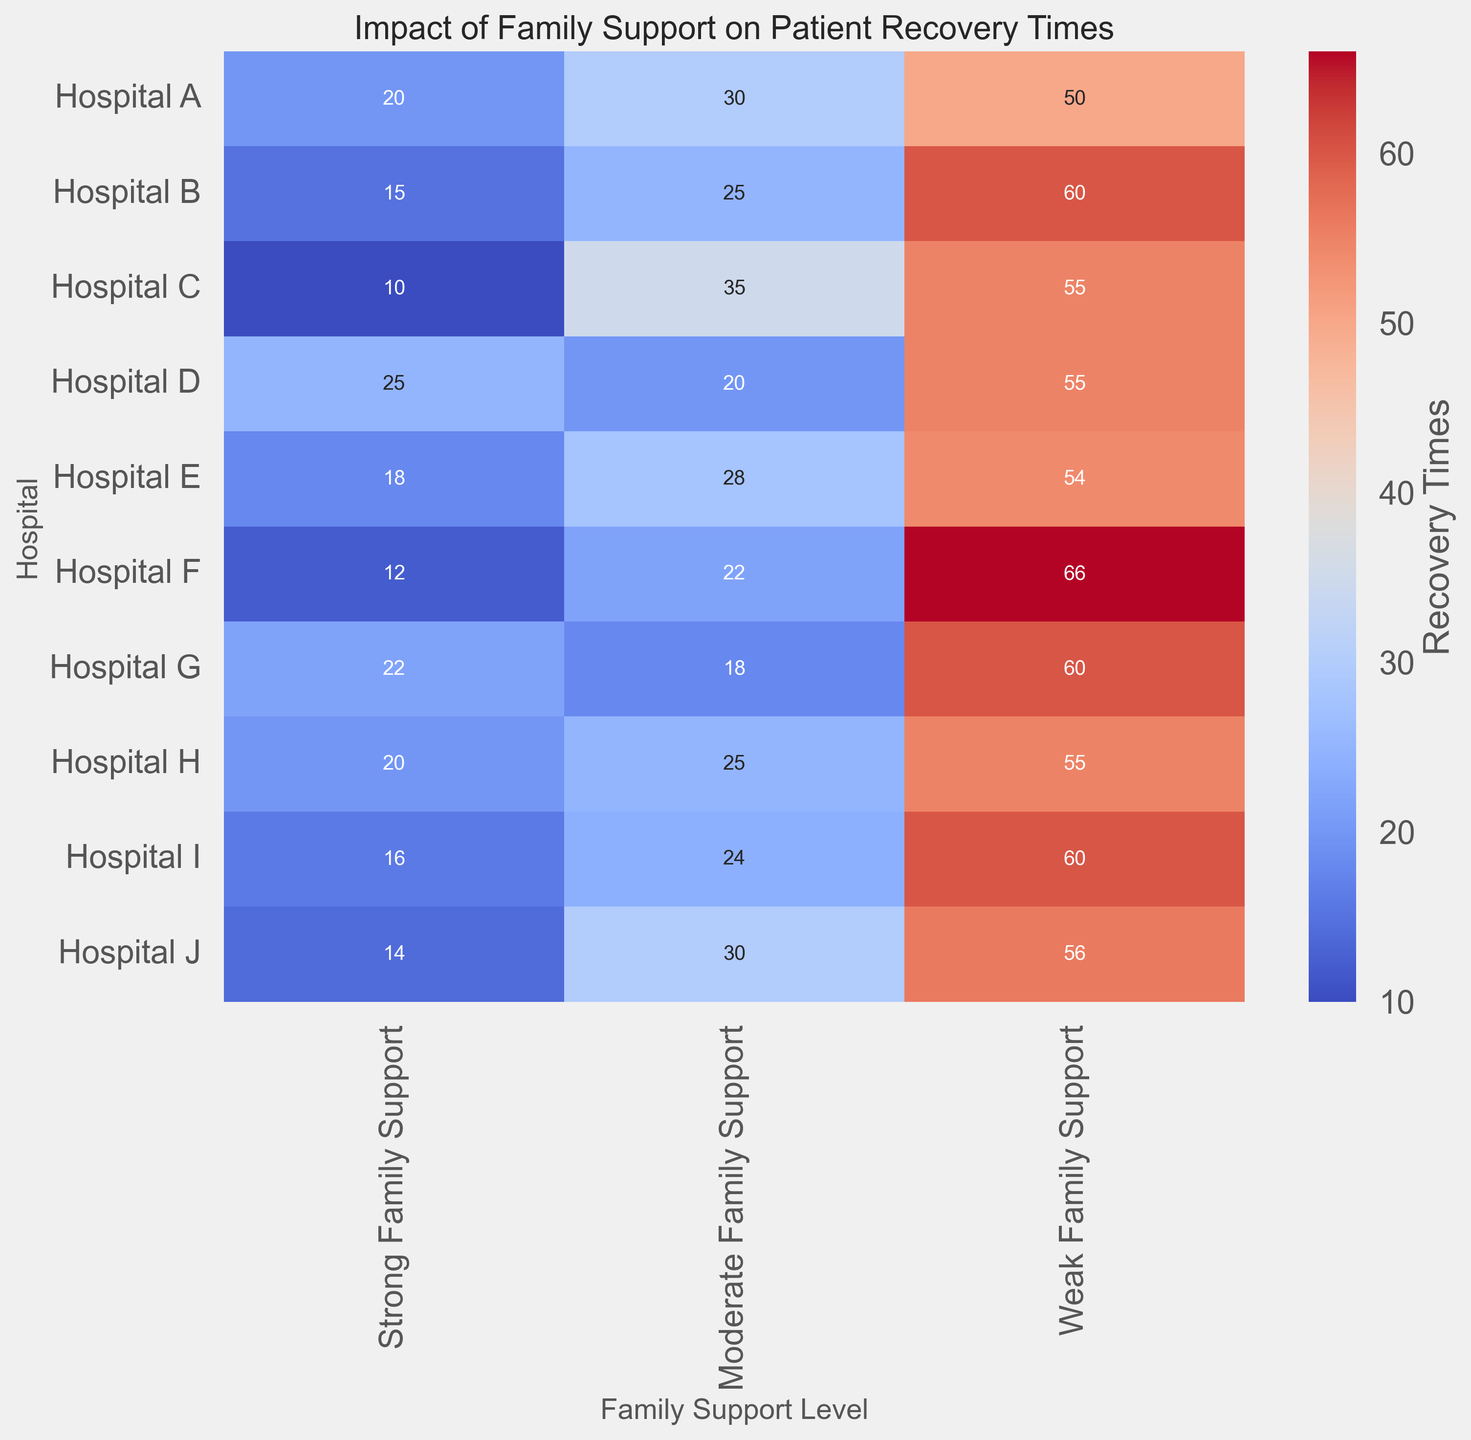What's the difference in recovery times between strong and weak family support structures in Hospital A? In Hospital A, the recovery time under strong family support is 20, and under weak family support, it is 50. The difference is calculated by subtracting 20 from 50.
Answer: 30 Which hospital shows the least difference in recovery times between moderate and weak family support? By comparing the differences, Hospital C shows a difference of 20 (55 - 35), which is less than any other hospital where the difference is more significant.
Answer: Hospital C Which hospital has the highest recovery time for weak family support? The hospital with the highest number in the weak family support column is Hospital F, with a recovery time of 66.
Answer: Hospital F What is the total recovery time for Hospital E across all family support levels? Adding the recovery times of Hospital E across all levels: 18 (Strong) + 28 (Moderate) + 54 (Weak) = 100.
Answer: 100 Between Hospitals D and G, which one has a higher recovery time for strong family support? Strong family support recovery times are 25 for Hospital D and 22 for Hospital G. Thus, Hospital D has the higher recovery time.
Answer: Hospital D Is there any hospital where the recovery time is equal across strong, moderate, and weak family support? Upon examining all three support levels in each hospital, no hospital has equal recovery times across all support levels. Each has different numbers.
Answer: No What's the average recovery time for moderate family support among all hospitals? To find the average, sum the moderate family support times: 30 + 25 + 35 + 20 + 28 + 22 + 18 + 25 + 24 + 30 = 257, then divide by the number of hospitals (10): 257/10 = 25.7.
Answer: 25.7 Which family support level seems to correlate with the lowest recovery time across most hospitals? By quickly observing the color intensity towards the cooler shades (lower recovery times), the strong family support column generally has lower numbers compared to moderate and weak support levels in most hospitals.
Answer: Strong Family Support Which hospitals have the highest recovery time in the moderate family support category? Upon checking the moderate family support column, Hospitals A and J both have a recovery time of 30, which is the highest.
Answer: Hospitals A and J How does the recovery time in Hospital B with strong family support compare to Hospital J with moderate family support? Hospital B has a recovery time of 15 with strong family support, and Hospital J has a recovery time of 30 with moderate family support. Comparing the two, Hospital J's moderate support recovery time is higher.
Answer: Hospital J 